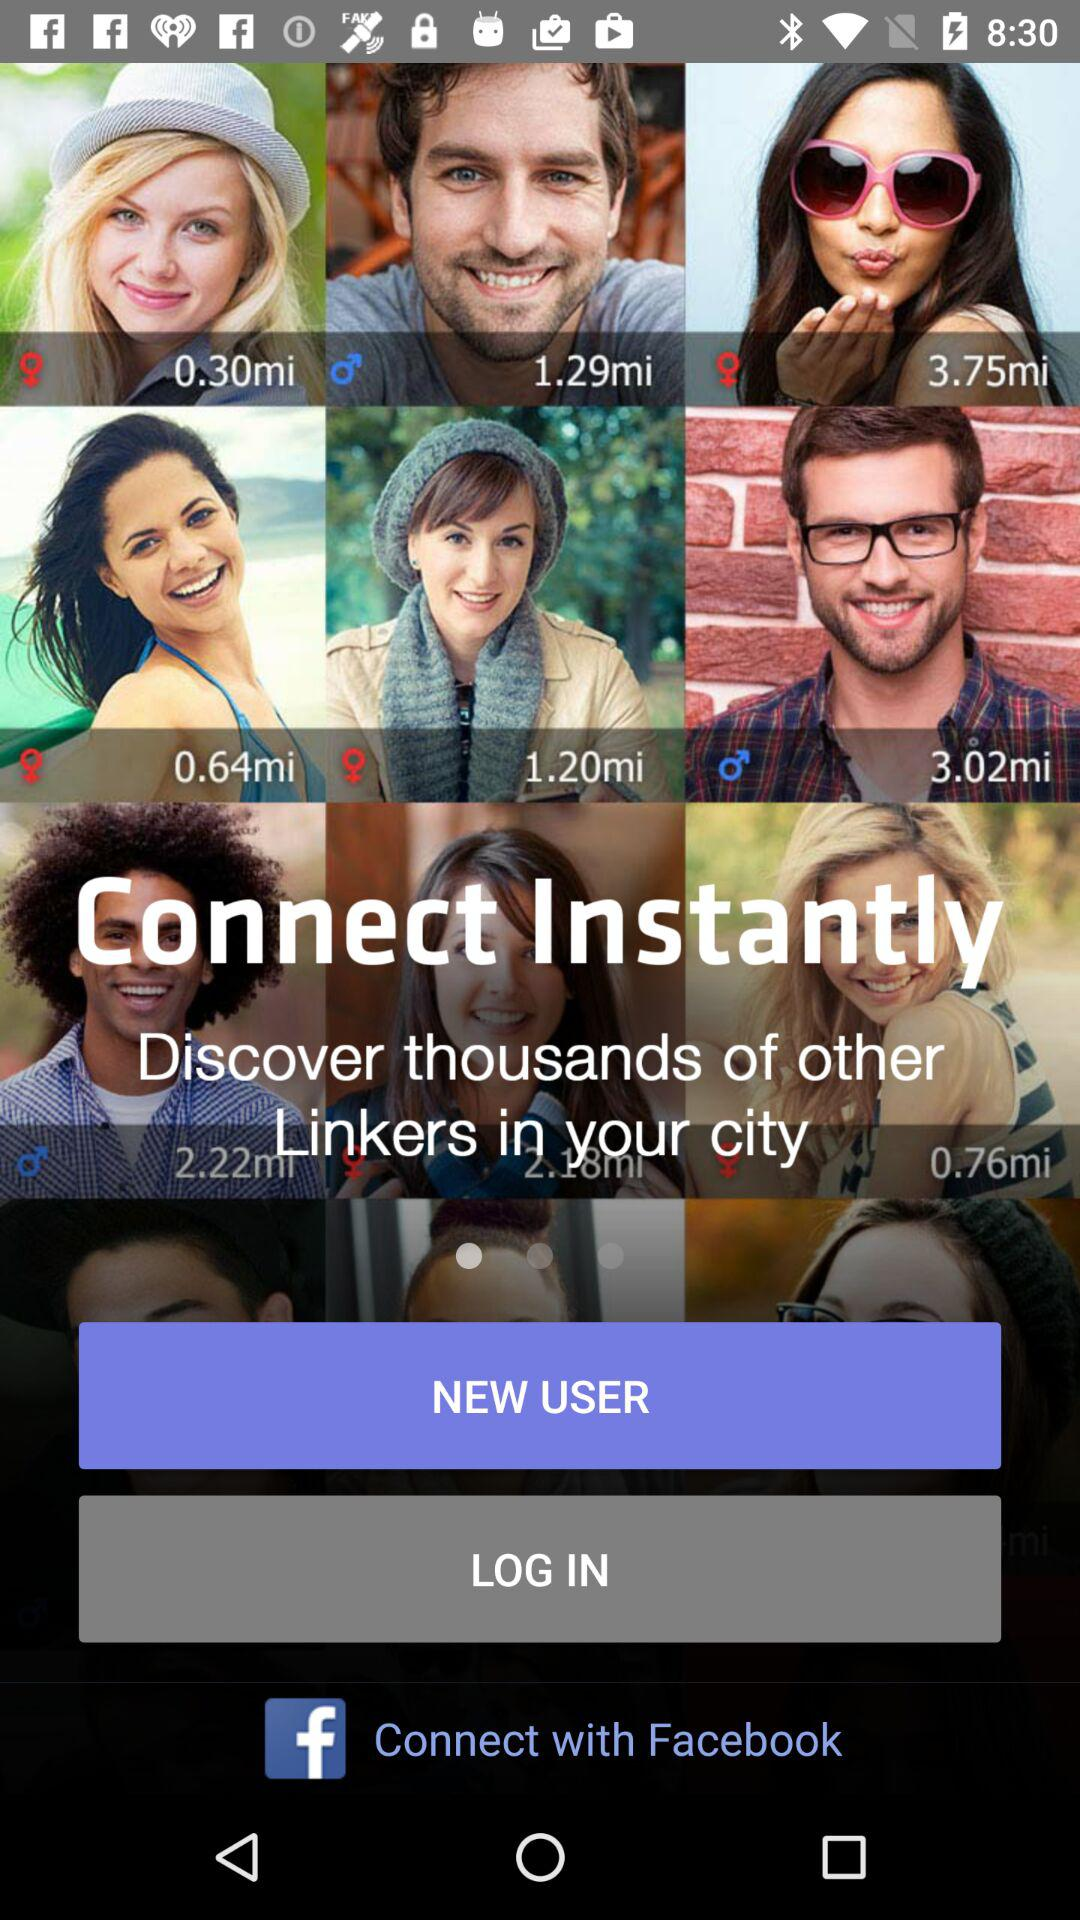What is the app name? The app name is "Facebook". 